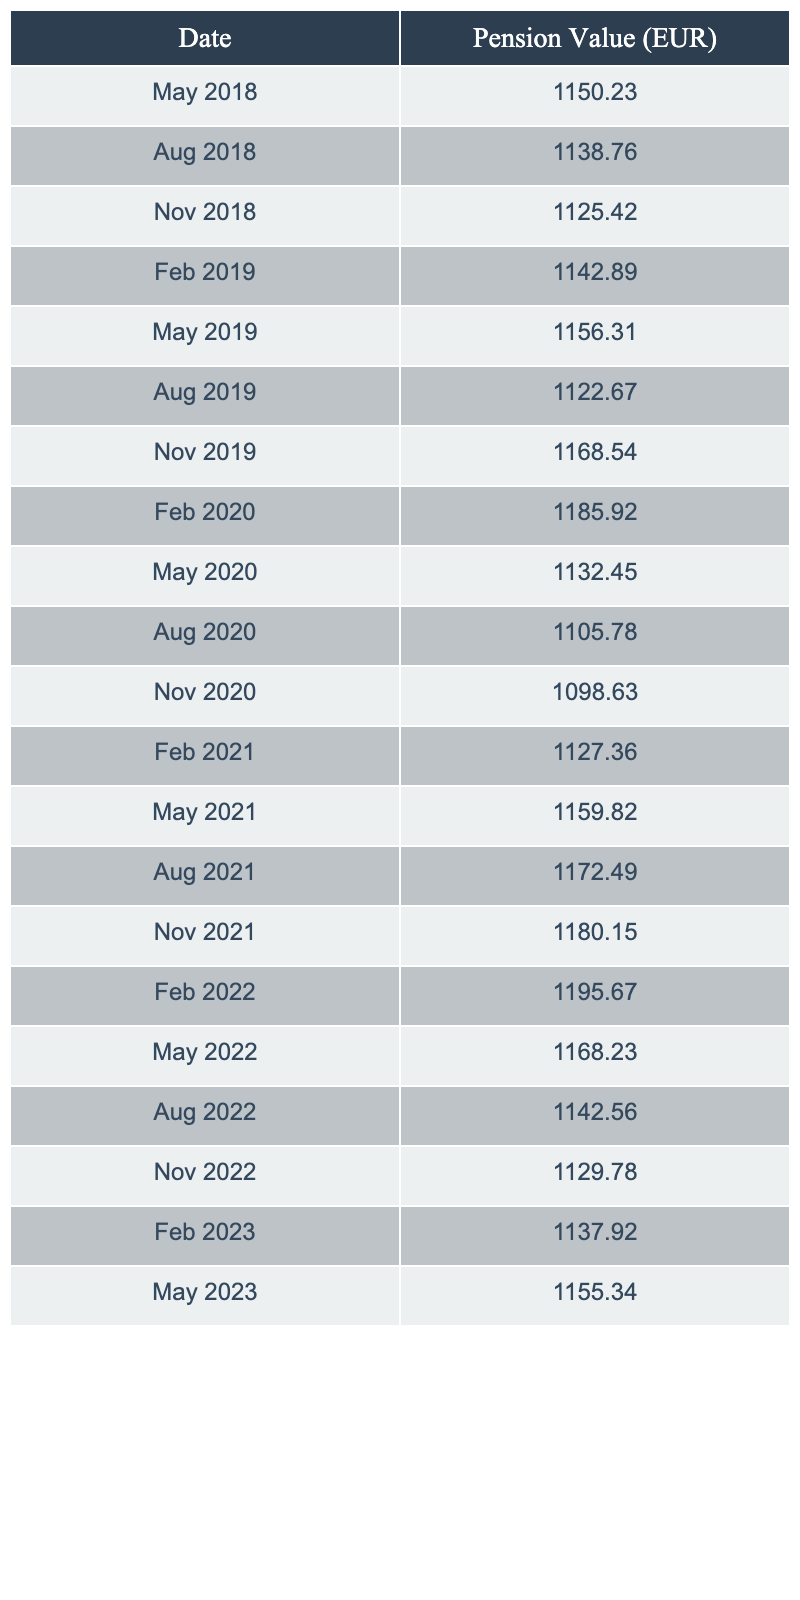What was the pension value in May 2021? In the table, I look for the row where the date is May 2021, which corresponds to the value in that row. The pension value for May 2021 is 1159.82 euros.
Answer: 1159.82 Which month had the highest pension value in euros over these five years? To find the highest value, I compare all the pension values listed in the table. The highest pension value is 1195.67 euros, which was recorded in February 2022.
Answer: February 2022 What is the difference in pension value between November 2019 and November 2020? I find the values for both November 2019 and November 2020 in the table. The value for November 2019 is 1168.54 euros and for November 2020 is 1098.63 euros. To find the difference, I subtract: 1168.54 - 1098.63 = 69.91 euros.
Answer: 69.91 What is the average pension value over the five years? To calculate the average, I sum up all the pension values listed in the table and then divide by the number of entries (20). The total is 23,344.99 euros, so the average is 23,344.99 / 20 = 1167.25 euros.
Answer: 1167.25 Is the pension value in May 2022 higher than that in May 2021? I compare the values for May 2021 (1159.82 euros) and May 2022 (1168.23 euros). Since 1168.23 is greater than 1159.82, the statement is true.
Answer: Yes How many times did the pension value exceed 1150 euros in this period? I check all the pension values listed and count those that are above 1150 euros. These are found in 10 instances (all values from February 2019 onwards, except one in August 2020).
Answer: 10 times What was the minimum pension value recorded during this period? I review all the values in the table and identify the lowest one, which is noted as 1098.63 euros in November 2020.
Answer: 1098.63 Which quarter had the highest average pension value based on the data? I first divide the data by quarters. Q1 (Jan-Mar) averages to 1155.67, Q2 (Apr-Jun) is 1155.81, Q3 (Jul-Sep) averages to 1132.05, and Q4 (Oct-Dec) comes to 1166.19. The highest average is in Q2 with 1159.00 euros.
Answer: Q2 Was there a decrease in pension value from August 2020 to November 2020? I compare the values for August 2020 (1105.78 euros) and November 2020 (1098.63 euros). Since 1098.63 is less than 1105.78, it indicates a decrease in value.
Answer: Yes What was the pension value trend from 2018 to 2023? I assess the values over the years from the table, noting that there was a general increase from 2018 to 2022, with some fluctuations, and a slight drop in 2020-2021 suggesting a mixed trend, but ultimately ending with a slight increase in 2023 compared to 2022.
Answer: Mixed trend with overall increase 